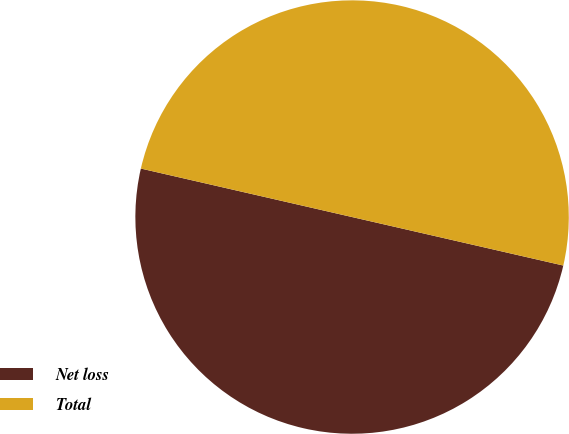Convert chart to OTSL. <chart><loc_0><loc_0><loc_500><loc_500><pie_chart><fcel>Net loss<fcel>Total<nl><fcel>50.0%<fcel>50.0%<nl></chart> 